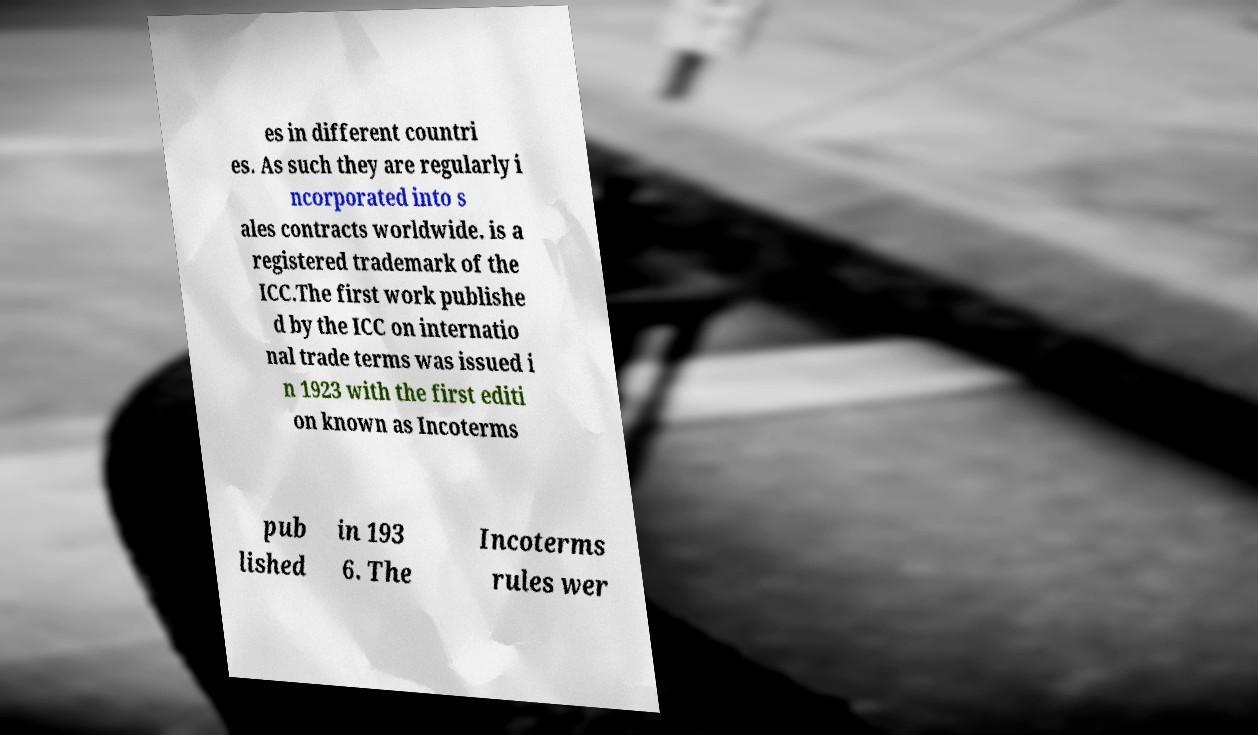There's text embedded in this image that I need extracted. Can you transcribe it verbatim? es in different countri es. As such they are regularly i ncorporated into s ales contracts worldwide. is a registered trademark of the ICC.The first work publishe d by the ICC on internatio nal trade terms was issued i n 1923 with the first editi on known as Incoterms pub lished in 193 6. The Incoterms rules wer 